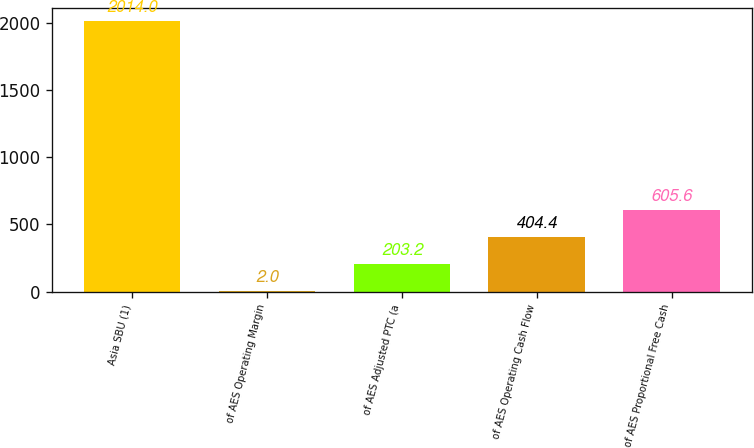Convert chart. <chart><loc_0><loc_0><loc_500><loc_500><bar_chart><fcel>Asia SBU (1)<fcel>of AES Operating Margin<fcel>of AES Adjusted PTC (a<fcel>of AES Operating Cash Flow<fcel>of AES Proportional Free Cash<nl><fcel>2014<fcel>2<fcel>203.2<fcel>404.4<fcel>605.6<nl></chart> 